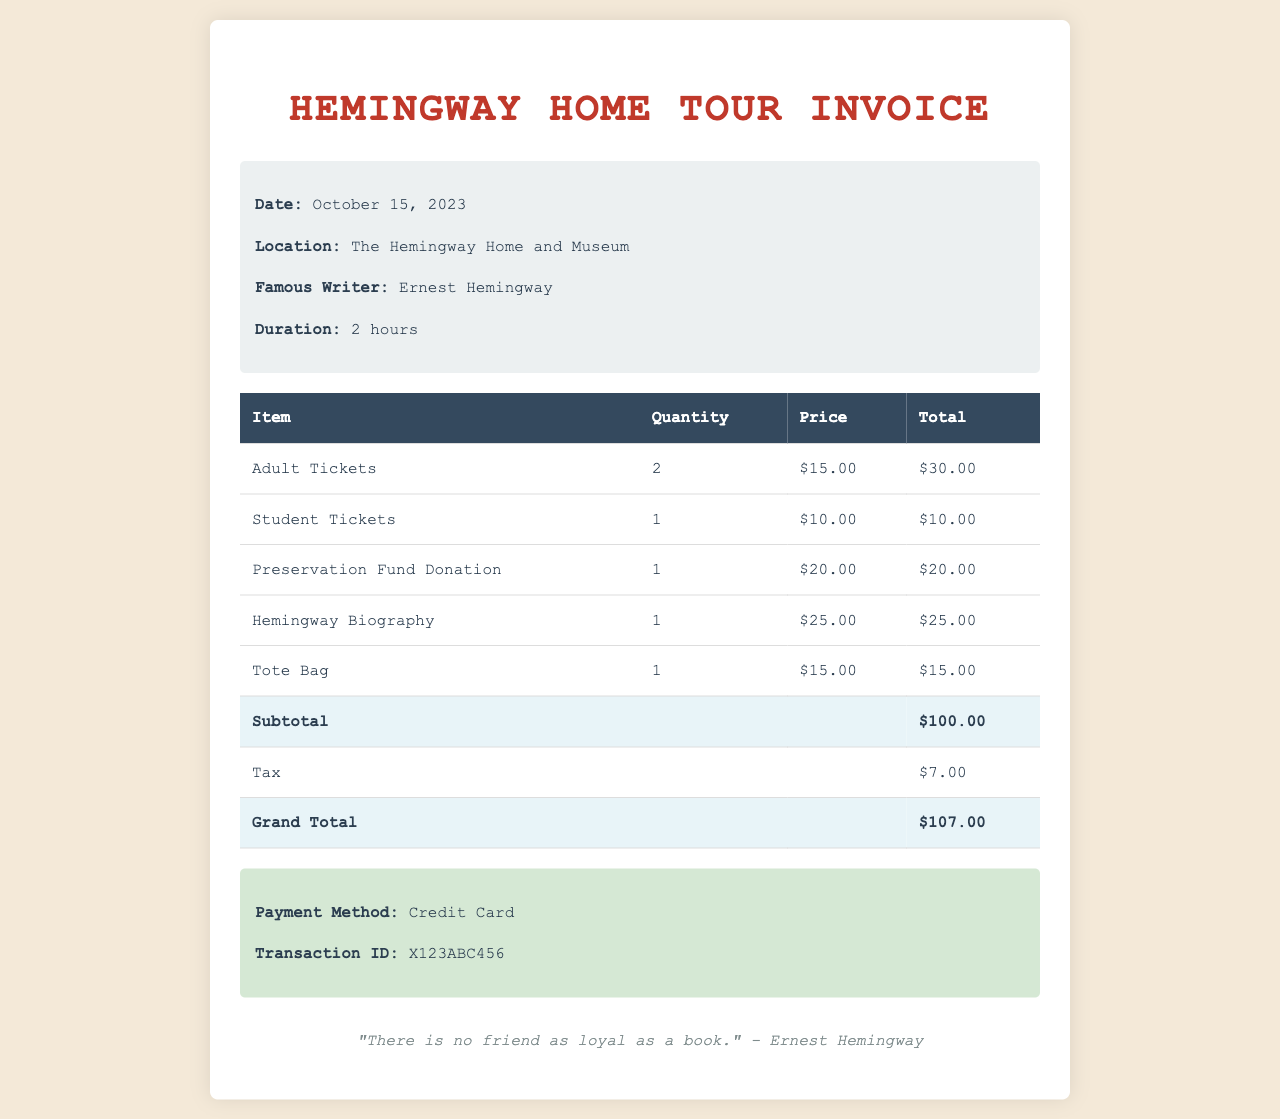What is the date of the tour? The date of the tour is mentioned in the tour details section of the document.
Answer: October 15, 2023 How many adult tickets were purchased? The document lists the quantity of adult tickets in the itemized section.
Answer: 2 What is the total price of the merchandise purchased? The total price is found by adding the prices of the merchandise items listed in the invoice.
Answer: $40.00 What is the transaction ID for the payment? The transaction ID is specified in the payment information part of the invoice.
Answer: X123ABC456 What was the total amount paid including tax? The grand total provides the total amount paid after adding tax to the subtotal.
Answer: $107.00 What famous writer is associated with the location of the tour? The document indicates the famous writer in the tour details section.
Answer: Ernest Hemingway How much was donated to the preservation fund? The donation amount can be found in the itemized fees table under the preservation fund donation line.
Answer: $20.00 What payment method was used for the transaction? The payment method is noted in the payment information section of the invoice.
Answer: Credit Card 